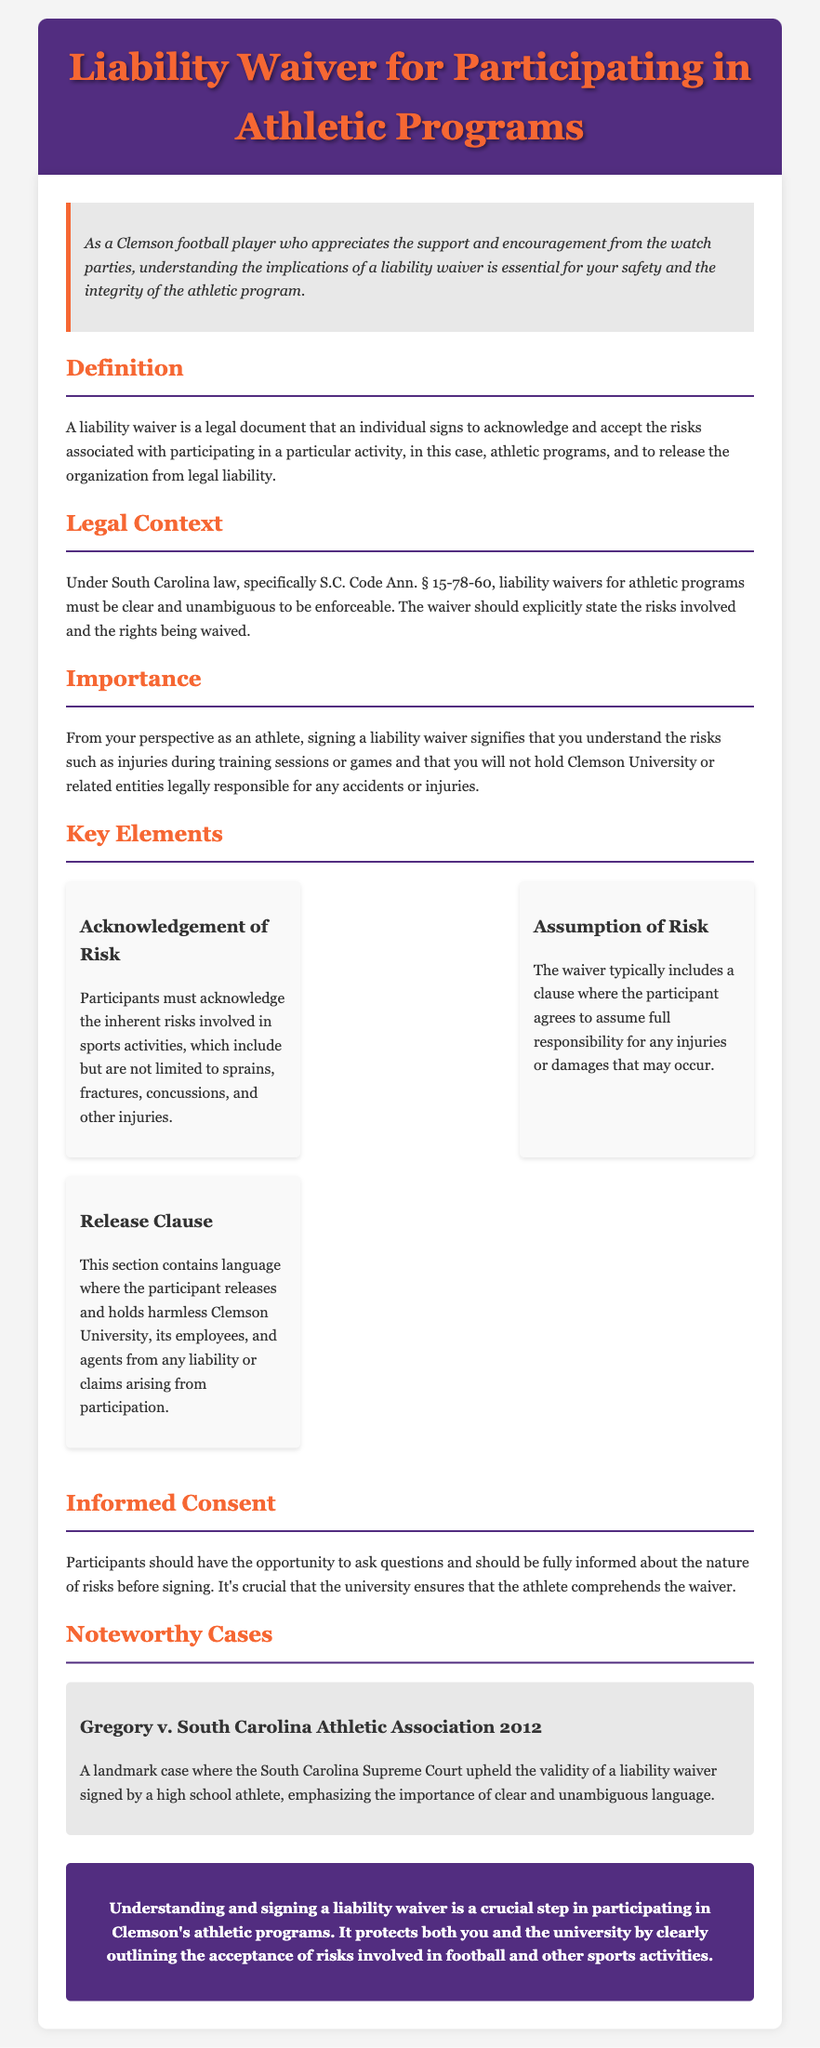What is a liability waiver? A liability waiver is a legal document that an individual signs to acknowledge and accept the risks associated with participating in a particular activity.
Answer: legal document What section discusses the legal context of waivers in South Carolina? The legal context of waivers is found under South Carolina law, specifically S.C. Code Ann. § 15-78-60.
Answer: S.C. Code Ann. § 15-78-60 What inherent risks are acknowledged in the waiver? Participants must acknowledge the inherent risks involved in sports activities, including sprains, fractures, concussions, and other injuries.
Answer: sprains, fractures, concussions What is the purpose of the release clause? The release clause contains language where the participant releases and holds harmless Clemson University from any liability or claims arising from participation.
Answer: releases and holds harmless Which case upheld the validity of a liability waiver? The case that upheld the validity of a liability waiver is Gregory v. South Carolina Athletic Association.
Answer: Gregory v. South Carolina Athletic Association What must participants have the opportunity to do before signing? Participants should have the opportunity to ask questions and should be fully informed about the nature of risks before signing.
Answer: ask questions What is the significance of signing a liability waiver? Signing a liability waiver signifies that the participant understands the risks and will not hold the organization legally responsible.
Answer: understanding risks What color is the header background of the document? The header background color of the document is #522D80.
Answer: #522D80 